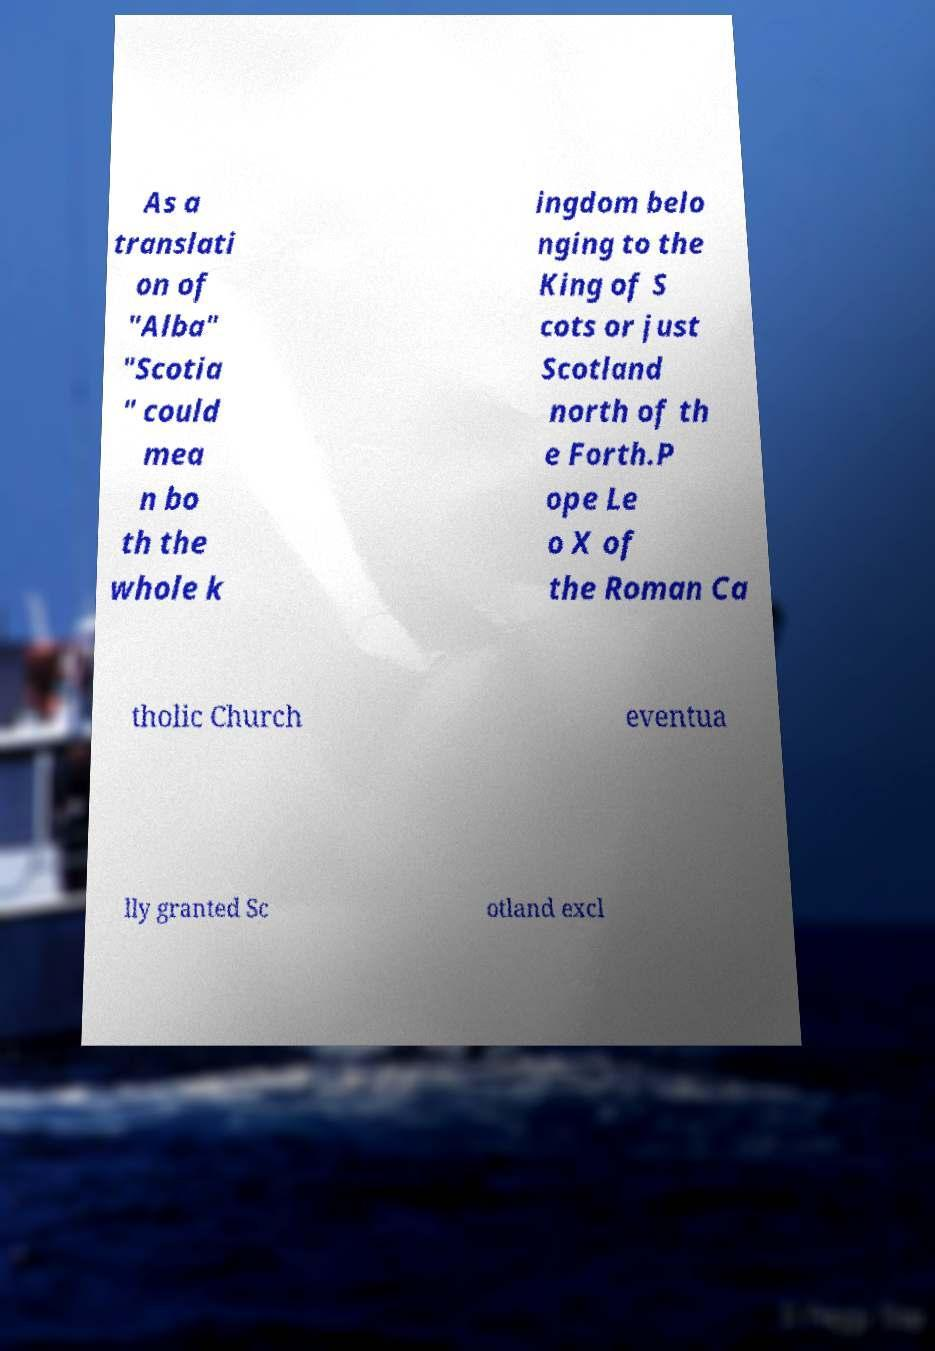Could you extract and type out the text from this image? As a translati on of "Alba" "Scotia " could mea n bo th the whole k ingdom belo nging to the King of S cots or just Scotland north of th e Forth.P ope Le o X of the Roman Ca tholic Church eventua lly granted Sc otland excl 